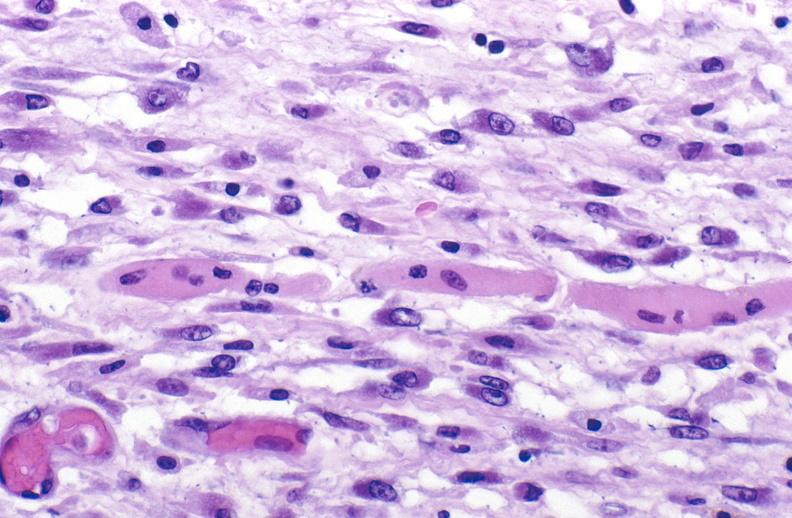what is present?
Answer the question using a single word or phrase. Soft tissue 